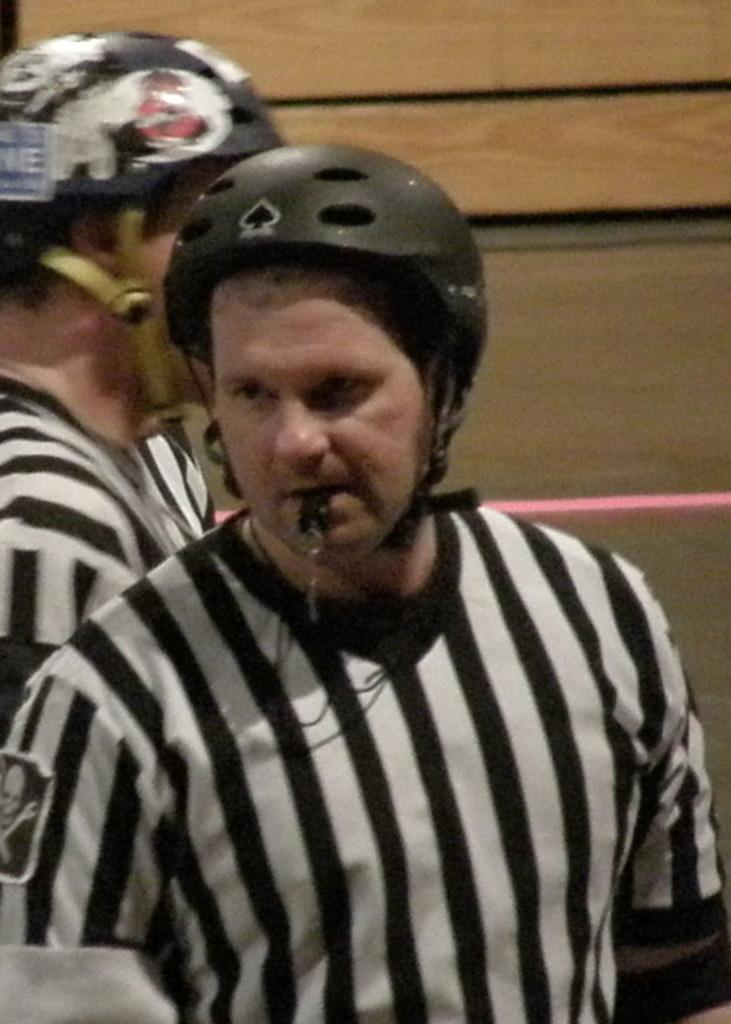How many people are in the image? There are two persons in the image. What are the persons wearing on their heads? Both persons are wearing helmets. How many ants can be seen crawling on the persons' helmets in the image? There are no ants visible in the image, as it only features two persons wearing helmets. 